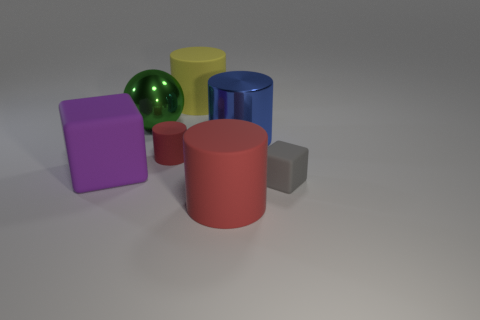What material is the object that is the same color as the small cylinder?
Give a very brief answer. Rubber. There is a yellow thing that is the same size as the purple rubber thing; what is its material?
Offer a very short reply. Rubber. Is there a brown rubber sphere that has the same size as the blue metal cylinder?
Offer a terse response. No. Do the yellow thing and the big blue thing have the same shape?
Ensure brevity in your answer.  Yes. Is there a blue metal thing that is left of the cylinder that is in front of the tiny rubber object left of the small gray cube?
Ensure brevity in your answer.  No. How many other objects are there of the same color as the small rubber cylinder?
Make the answer very short. 1. There is a matte cube to the right of the large metallic cylinder; does it have the same size as the cube that is to the left of the large red matte cylinder?
Your answer should be compact. No. Are there an equal number of metal cylinders in front of the purple object and rubber cylinders to the left of the metallic sphere?
Ensure brevity in your answer.  Yes. Do the sphere and the rubber cube to the right of the large sphere have the same size?
Your answer should be very brief. No. The large thing that is to the right of the cylinder that is in front of the small red matte thing is made of what material?
Ensure brevity in your answer.  Metal. 